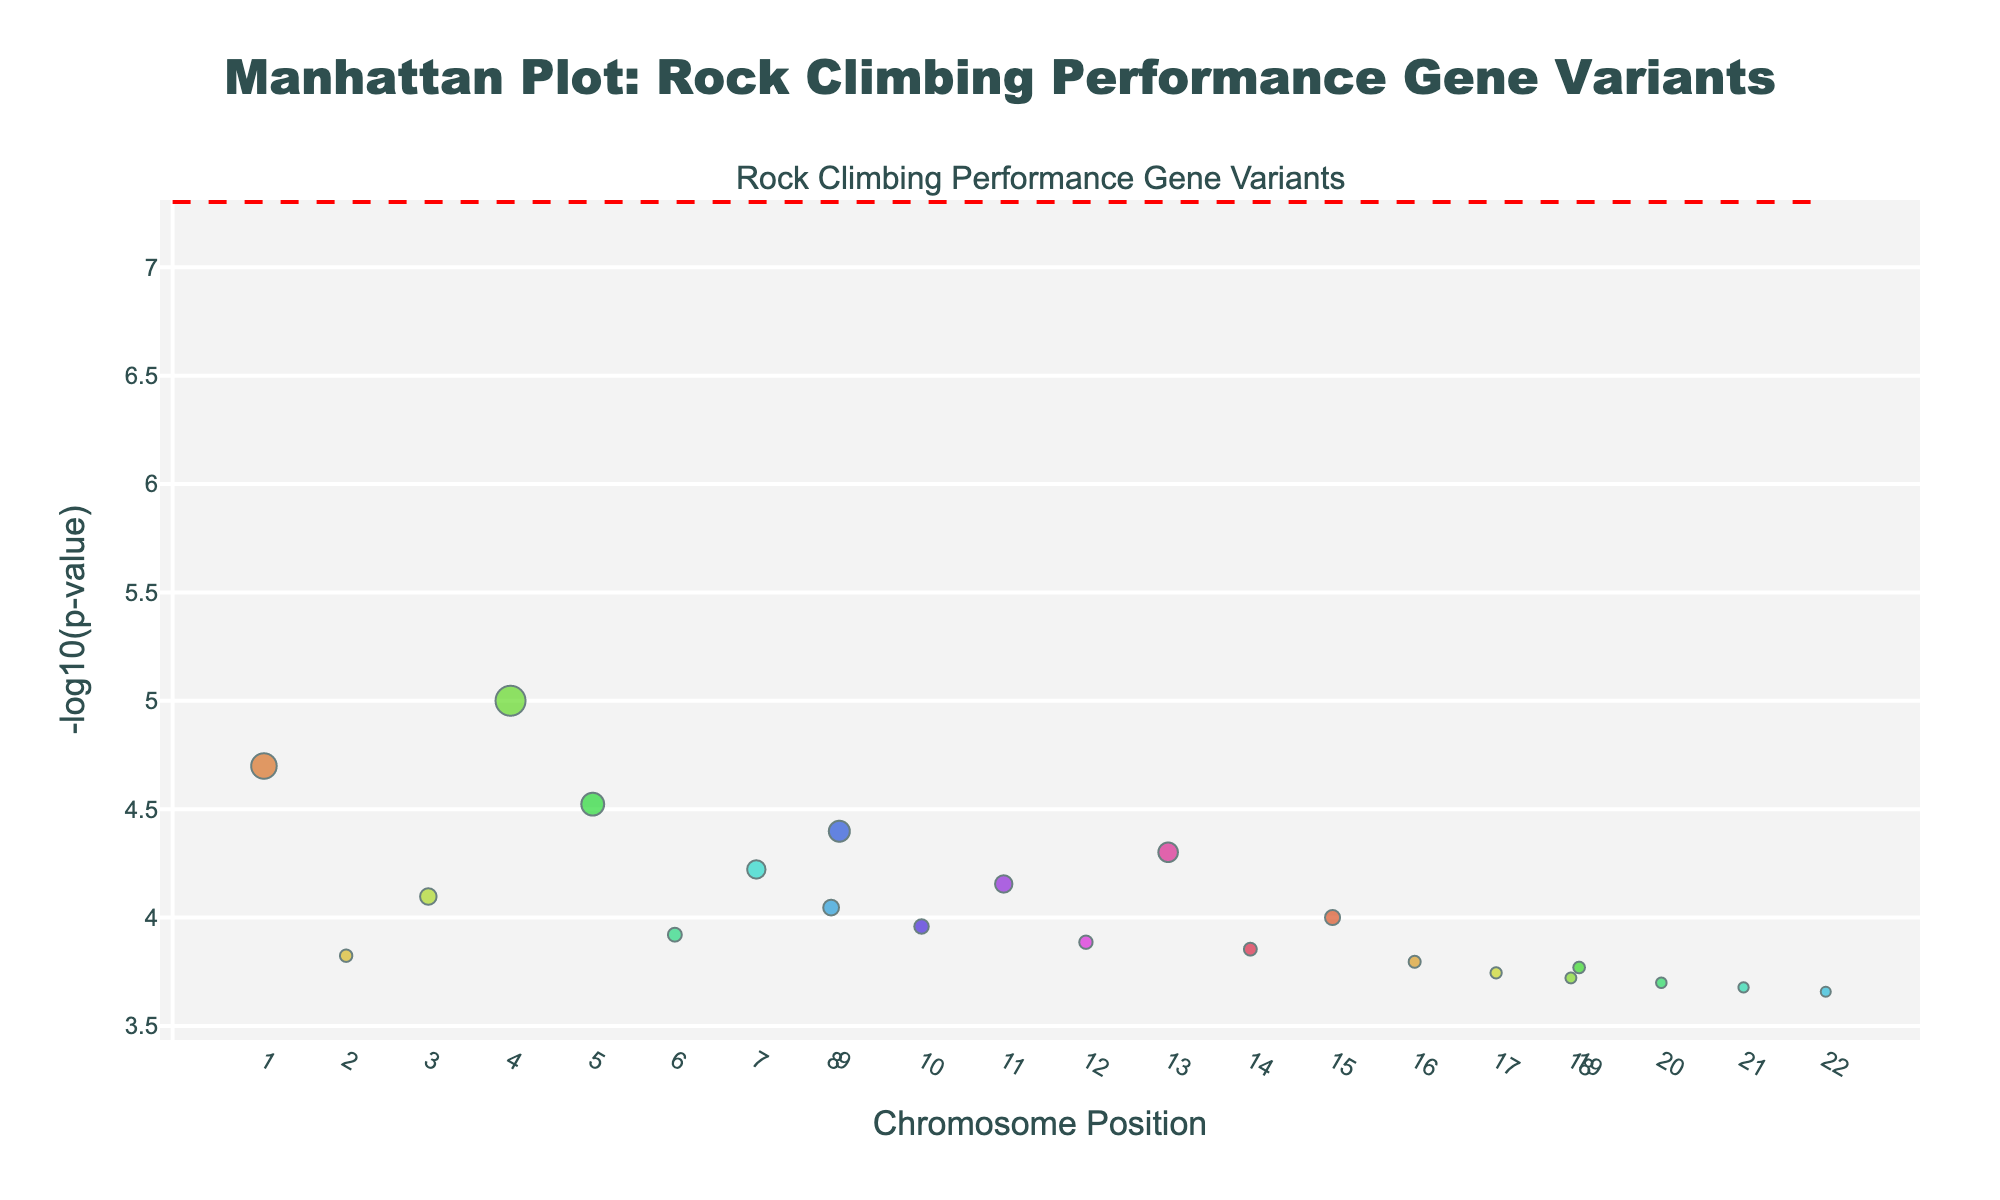What is the title of the plot? The title of the plot is written at the top of the figure. It reads, "Manhattan Plot: Rock Climbing Performance Gene Variants".
Answer: Manhattan Plot: Rock Climbing Performance Gene Variants Which chromosome has the highest -log10(p-value)? To find this, look for the highest point on the y-axis and check the corresponding chromosome color or label on the x-axis. The highest -log10(p-value) corresponds to a gene on Chromosome 4.
Answer: Chromosome 4 How many distinct chromosomes are represented in the plot? The x-axis has tick labels for each chromosome, corresponding to the number of distinct chromosomes. Counting these, we see that 22 distinct chromosomes are represented.
Answer: 22 Which gene has the smallest p-value in the plot? The gene with the smallest p-value will have the highest -log10(p-value). By examining the highest point on the y-axis, we see it is the ACE gene.
Answer: ACE How does the p-value of the gene on Chromosome 8 compare to the gene on Chromosome 10? The p-values are represented by the y-axis. Chromosome 8 (HIF1A) has a -log10(p) around 4.09, and Chromosome 10 (AMPD1) has a -log10(p) around 3.96. Higher -log10(p) values mean lower p-values. Therefore, the gene on Chromosome 8 has a smaller p-value than the gene on Chromosome 10.
Answer: Chromosome 8 has a smaller p-value Which gene is represented by the largest marker size? The largest marker size corresponds to the highest -log10(p-value). By inspecting the largest marker size, we identify it as the ACTN3 gene.
Answer: ACTN3 What is the significance threshold indicated by the horizontal line on the plot? The horizontal line represents the significance threshold. Its y-position corresponds to -log10(5e-8). Calculating this gives us 7.3.
Answer: 7.3 